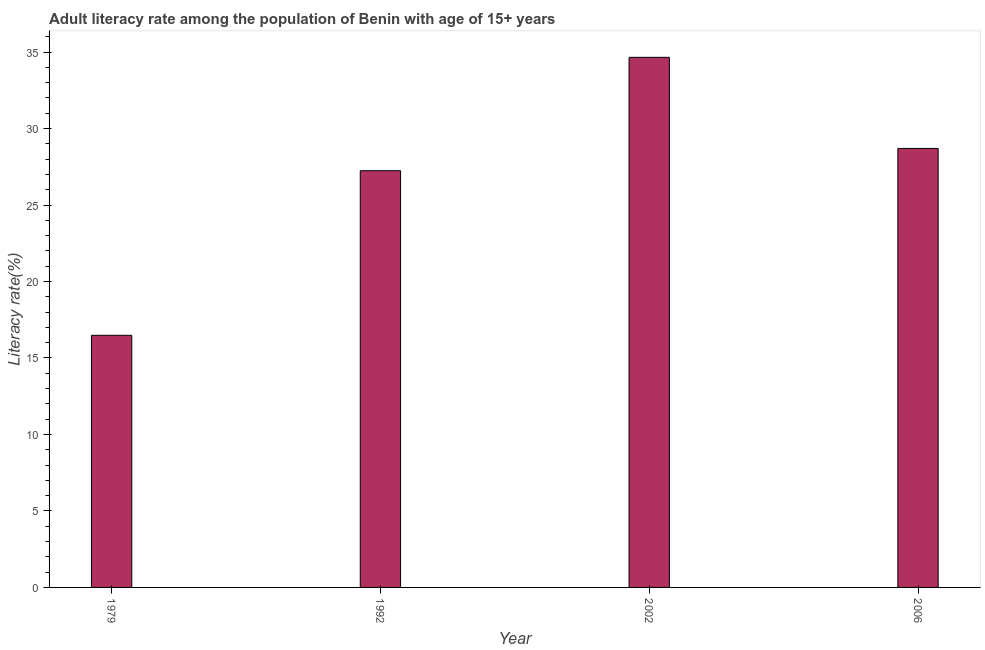Does the graph contain any zero values?
Make the answer very short. No. Does the graph contain grids?
Ensure brevity in your answer.  No. What is the title of the graph?
Provide a short and direct response. Adult literacy rate among the population of Benin with age of 15+ years. What is the label or title of the X-axis?
Provide a succinct answer. Year. What is the label or title of the Y-axis?
Your answer should be compact. Literacy rate(%). What is the adult literacy rate in 1992?
Your response must be concise. 27.25. Across all years, what is the maximum adult literacy rate?
Make the answer very short. 34.66. Across all years, what is the minimum adult literacy rate?
Your answer should be very brief. 16.48. In which year was the adult literacy rate minimum?
Offer a terse response. 1979. What is the sum of the adult literacy rate?
Provide a short and direct response. 107.09. What is the difference between the adult literacy rate in 1992 and 2006?
Your answer should be very brief. -1.46. What is the average adult literacy rate per year?
Ensure brevity in your answer.  26.77. What is the median adult literacy rate?
Give a very brief answer. 27.97. In how many years, is the adult literacy rate greater than 24 %?
Offer a very short reply. 3. Do a majority of the years between 2002 and 1979 (inclusive) have adult literacy rate greater than 21 %?
Offer a terse response. Yes. What is the ratio of the adult literacy rate in 2002 to that in 2006?
Make the answer very short. 1.21. Is the adult literacy rate in 2002 less than that in 2006?
Your response must be concise. No. What is the difference between the highest and the second highest adult literacy rate?
Make the answer very short. 5.96. What is the difference between the highest and the lowest adult literacy rate?
Your response must be concise. 18.18. How many bars are there?
Your answer should be compact. 4. Are all the bars in the graph horizontal?
Ensure brevity in your answer.  No. What is the Literacy rate(%) of 1979?
Provide a succinct answer. 16.48. What is the Literacy rate(%) in 1992?
Provide a short and direct response. 27.25. What is the Literacy rate(%) in 2002?
Your response must be concise. 34.66. What is the Literacy rate(%) of 2006?
Keep it short and to the point. 28.7. What is the difference between the Literacy rate(%) in 1979 and 1992?
Keep it short and to the point. -10.76. What is the difference between the Literacy rate(%) in 1979 and 2002?
Provide a short and direct response. -18.18. What is the difference between the Literacy rate(%) in 1979 and 2006?
Offer a terse response. -12.22. What is the difference between the Literacy rate(%) in 1992 and 2002?
Your answer should be very brief. -7.41. What is the difference between the Literacy rate(%) in 1992 and 2006?
Ensure brevity in your answer.  -1.46. What is the difference between the Literacy rate(%) in 2002 and 2006?
Your answer should be compact. 5.96. What is the ratio of the Literacy rate(%) in 1979 to that in 1992?
Keep it short and to the point. 0.6. What is the ratio of the Literacy rate(%) in 1979 to that in 2002?
Offer a very short reply. 0.48. What is the ratio of the Literacy rate(%) in 1979 to that in 2006?
Your response must be concise. 0.57. What is the ratio of the Literacy rate(%) in 1992 to that in 2002?
Give a very brief answer. 0.79. What is the ratio of the Literacy rate(%) in 1992 to that in 2006?
Your answer should be compact. 0.95. What is the ratio of the Literacy rate(%) in 2002 to that in 2006?
Provide a short and direct response. 1.21. 